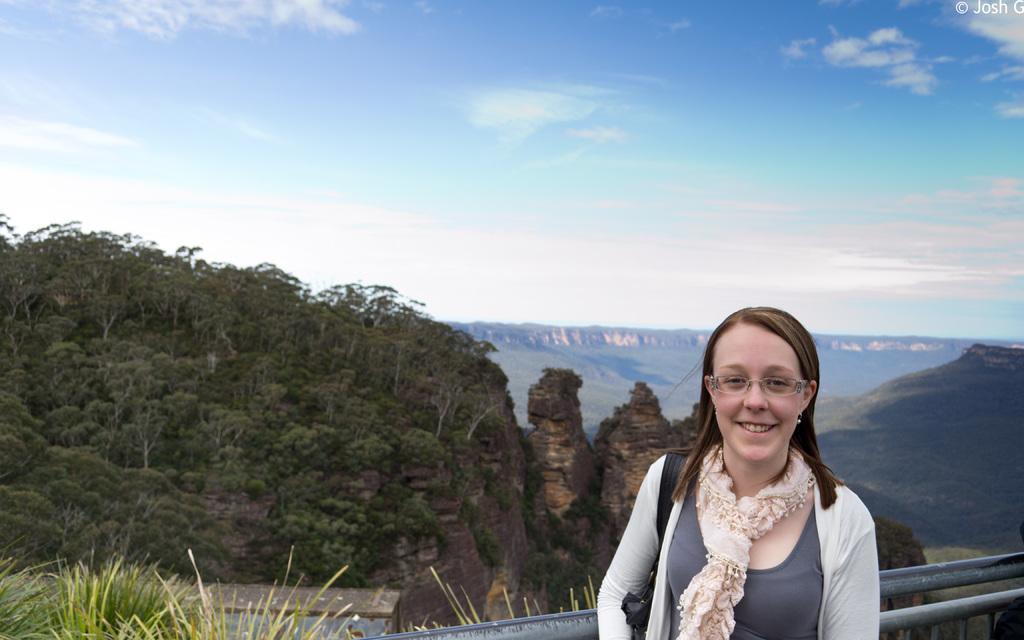Who is present on the right side of the image? There is a lady standing on the right side of the image. What is the lady doing in the image? The lady is smiling in the image. What can be seen at the bottom of the image? There is a fence at the bottom of the image. What type of landscape is visible in the background of the image? There are hills in the background of the image, and the sky is also visible. What type of cake is the lady eating in the image? There is no cake present in the image; the lady is simply standing and smiling. How many beans can be seen on the lady's clothing in the image? There are no beans visible on the lady's clothing in the image. 